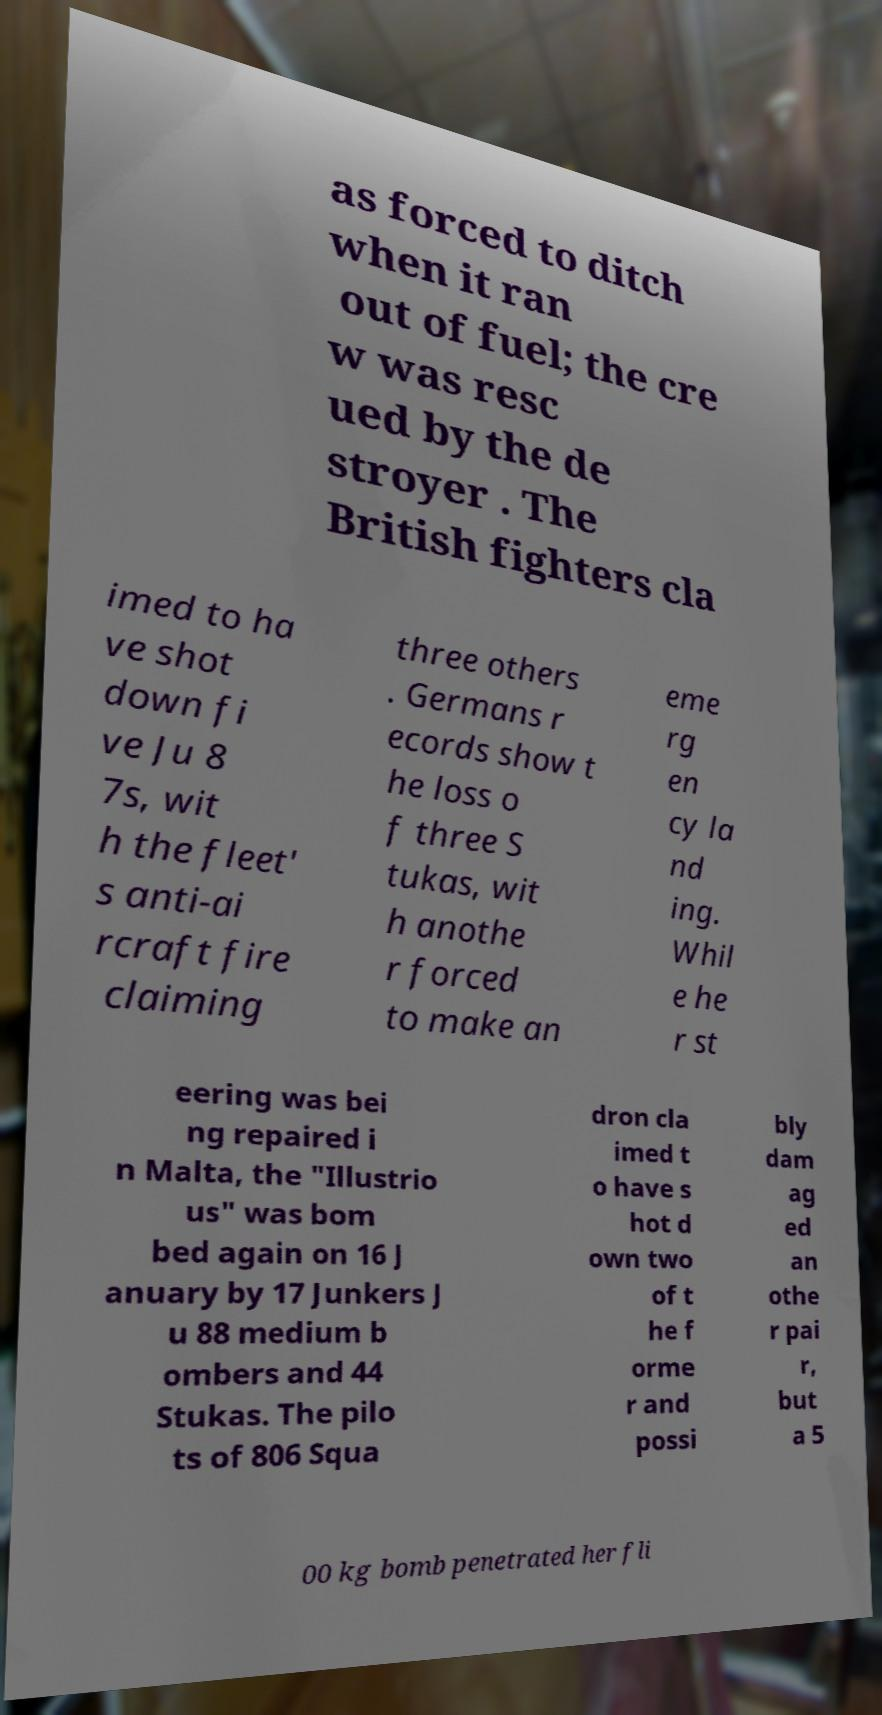There's text embedded in this image that I need extracted. Can you transcribe it verbatim? as forced to ditch when it ran out of fuel; the cre w was resc ued by the de stroyer . The British fighters cla imed to ha ve shot down fi ve Ju 8 7s, wit h the fleet' s anti-ai rcraft fire claiming three others . Germans r ecords show t he loss o f three S tukas, wit h anothe r forced to make an eme rg en cy la nd ing. Whil e he r st eering was bei ng repaired i n Malta, the "Illustrio us" was bom bed again on 16 J anuary by 17 Junkers J u 88 medium b ombers and 44 Stukas. The pilo ts of 806 Squa dron cla imed t o have s hot d own two of t he f orme r and possi bly dam ag ed an othe r pai r, but a 5 00 kg bomb penetrated her fli 